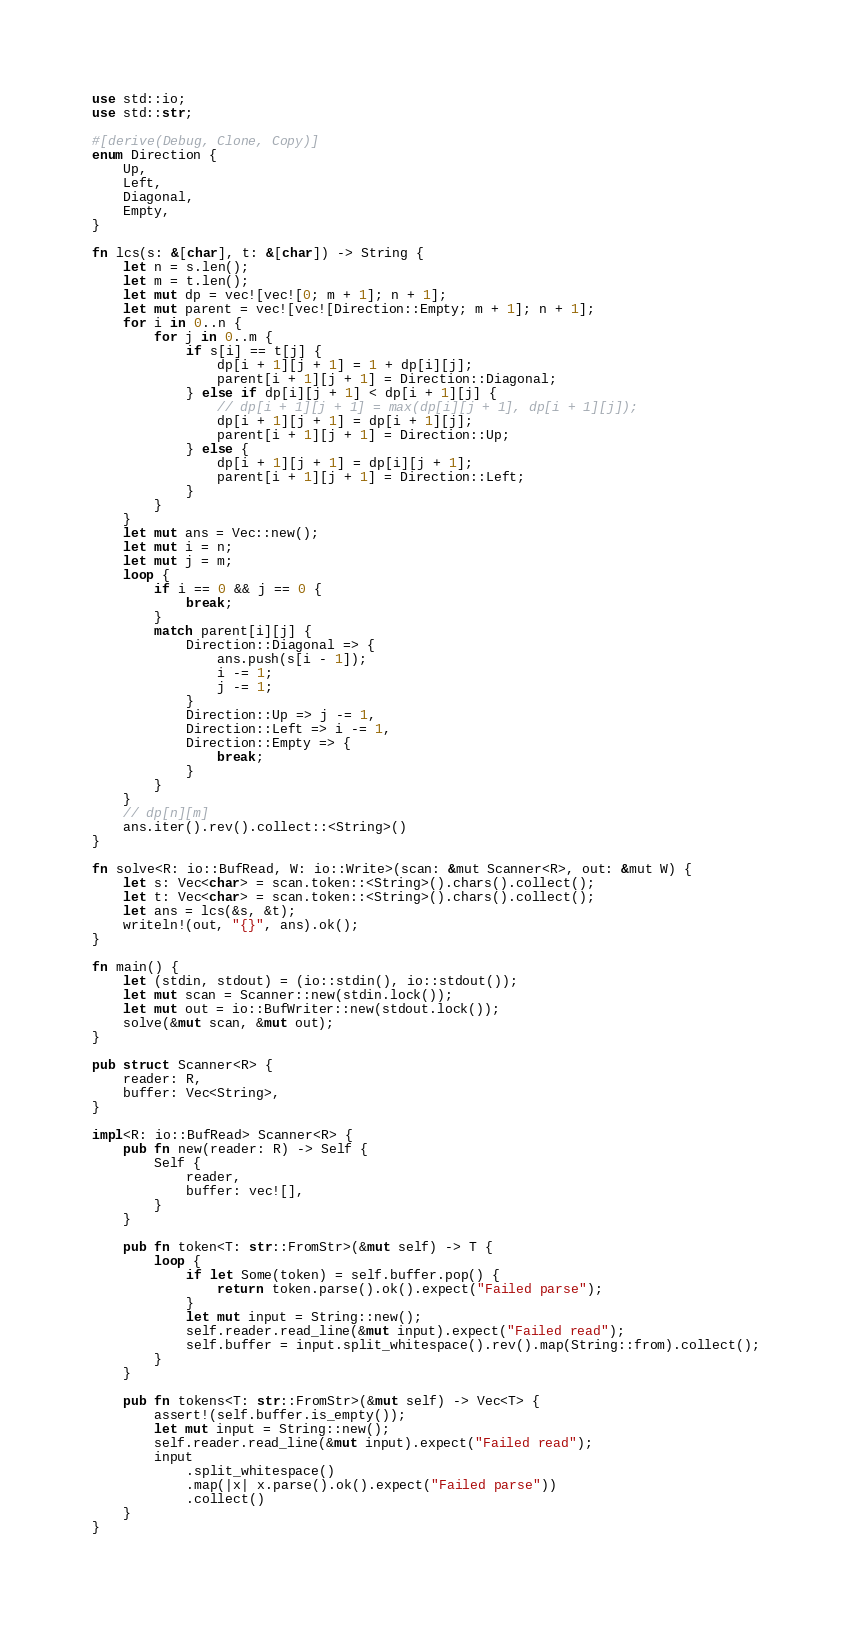<code> <loc_0><loc_0><loc_500><loc_500><_Rust_>use std::io;
use std::str;

#[derive(Debug, Clone, Copy)]
enum Direction {
    Up,
    Left,
    Diagonal,
    Empty,
}

fn lcs(s: &[char], t: &[char]) -> String {
    let n = s.len();
    let m = t.len();
    let mut dp = vec![vec![0; m + 1]; n + 1];
    let mut parent = vec![vec![Direction::Empty; m + 1]; n + 1];
    for i in 0..n {
        for j in 0..m {
            if s[i] == t[j] {
                dp[i + 1][j + 1] = 1 + dp[i][j];
                parent[i + 1][j + 1] = Direction::Diagonal;
            } else if dp[i][j + 1] < dp[i + 1][j] {
                // dp[i + 1][j + 1] = max(dp[i][j + 1], dp[i + 1][j]);
                dp[i + 1][j + 1] = dp[i + 1][j];
                parent[i + 1][j + 1] = Direction::Up;
            } else {
                dp[i + 1][j + 1] = dp[i][j + 1];
                parent[i + 1][j + 1] = Direction::Left;
            }
        }
    }
    let mut ans = Vec::new();
    let mut i = n;
    let mut j = m;
    loop {
        if i == 0 && j == 0 {
            break;
        }
        match parent[i][j] {
            Direction::Diagonal => {
                ans.push(s[i - 1]);
                i -= 1;
                j -= 1;
            }
            Direction::Up => j -= 1,
            Direction::Left => i -= 1,
            Direction::Empty => {
                break;
            }
        }
    }
    // dp[n][m]
    ans.iter().rev().collect::<String>()
}

fn solve<R: io::BufRead, W: io::Write>(scan: &mut Scanner<R>, out: &mut W) {
    let s: Vec<char> = scan.token::<String>().chars().collect();
    let t: Vec<char> = scan.token::<String>().chars().collect();
    let ans = lcs(&s, &t);
    writeln!(out, "{}", ans).ok();
}

fn main() {
    let (stdin, stdout) = (io::stdin(), io::stdout());
    let mut scan = Scanner::new(stdin.lock());
    let mut out = io::BufWriter::new(stdout.lock());
    solve(&mut scan, &mut out);
}

pub struct Scanner<R> {
    reader: R,
    buffer: Vec<String>,
}

impl<R: io::BufRead> Scanner<R> {
    pub fn new(reader: R) -> Self {
        Self {
            reader,
            buffer: vec![],
        }
    }

    pub fn token<T: str::FromStr>(&mut self) -> T {
        loop {
            if let Some(token) = self.buffer.pop() {
                return token.parse().ok().expect("Failed parse");
            }
            let mut input = String::new();
            self.reader.read_line(&mut input).expect("Failed read");
            self.buffer = input.split_whitespace().rev().map(String::from).collect();
        }
    }

    pub fn tokens<T: str::FromStr>(&mut self) -> Vec<T> {
        assert!(self.buffer.is_empty());
        let mut input = String::new();
        self.reader.read_line(&mut input).expect("Failed read");
        input
            .split_whitespace()
            .map(|x| x.parse().ok().expect("Failed parse"))
            .collect()
    }
}
</code> 